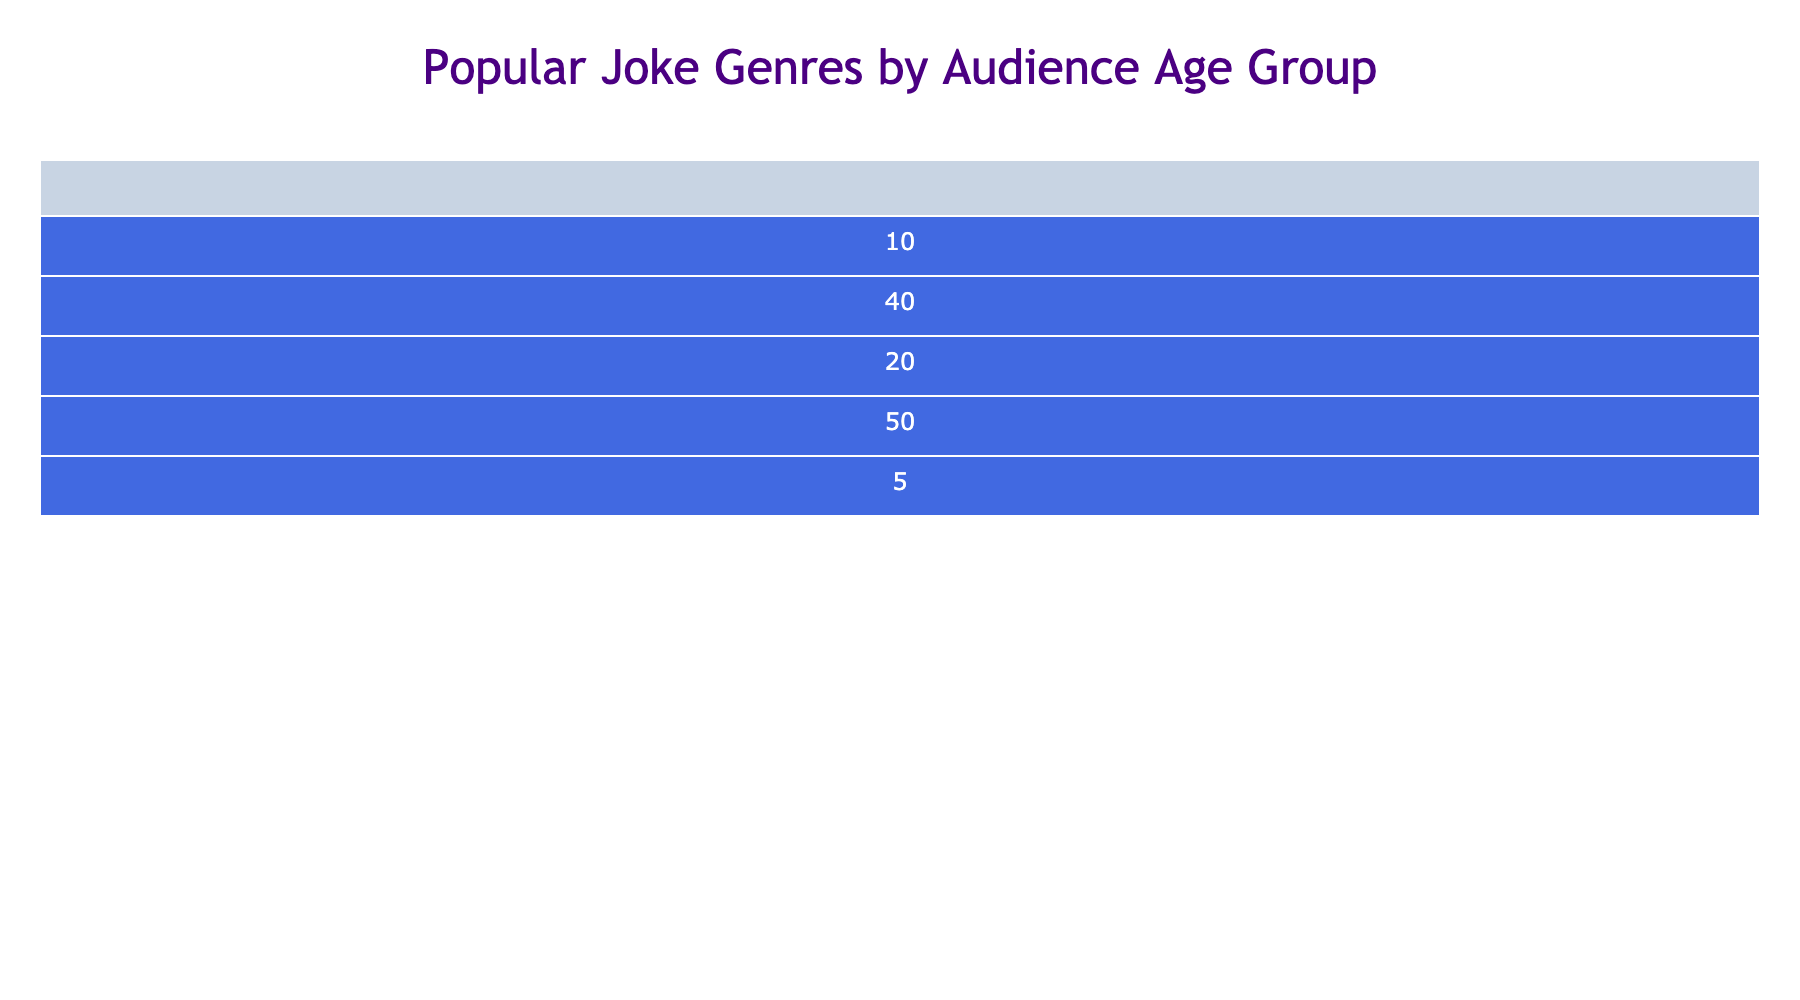What age group enjoys one-liners the most? By looking at the "One-liners" column in the table, we can see that the age group 18-24 has the highest number at 35.
Answer: 18-24 Which joke genre is least popular among the 55+ age group? In the "55+" row, we can see the lowest number corresponds to "Surreal Humor," which has the value of 5.
Answer: Surreal Humor What is the total popularity of observational humor across all age groups? To find the total popularity of "Observational Humor," we add the values from each age group: 40 (18-24) + 50 (25-34) + 60 (35-44) + 55 (45-54) + 40 (55+) = 245.
Answer: 245 Is dark humor more popular than puns among the 35-44 age group? In the 35-44 row, dark humor has a value of 30 and puns have a value of 40. Thus, dark humor is less popular than puns in this age group.
Answer: No What is the average popularity of puns among all age groups? We take the values for puns: 45 (18-24) + 50 (25-34) + 40 (35-44) + 30 (45-54) + 20 (55+) = 185. Then, we divide by the number of age groups, which is 5. So, 185 / 5 = 37.
Answer: 37 Which age group shows the highest preference for dark humor, and what is the value? We look at the "Dark Humor" column and find that the age group 55+ shows the highest preference with a value of 50.
Answer: 55+, 50 Is there an age group that prefers surreal humor over one-liners? By comparing the values in the respective columns for each age group, we note that no age group has a higher value for "Surreal Humor" than for "One-liners."
Answer: No What is the difference in popularity between observational humor for the age groups 25-34 and 35-44? For 25-34, the value is 50 and for 35-44, it’s 60. The difference is 60 - 50 = 10.
Answer: 10 